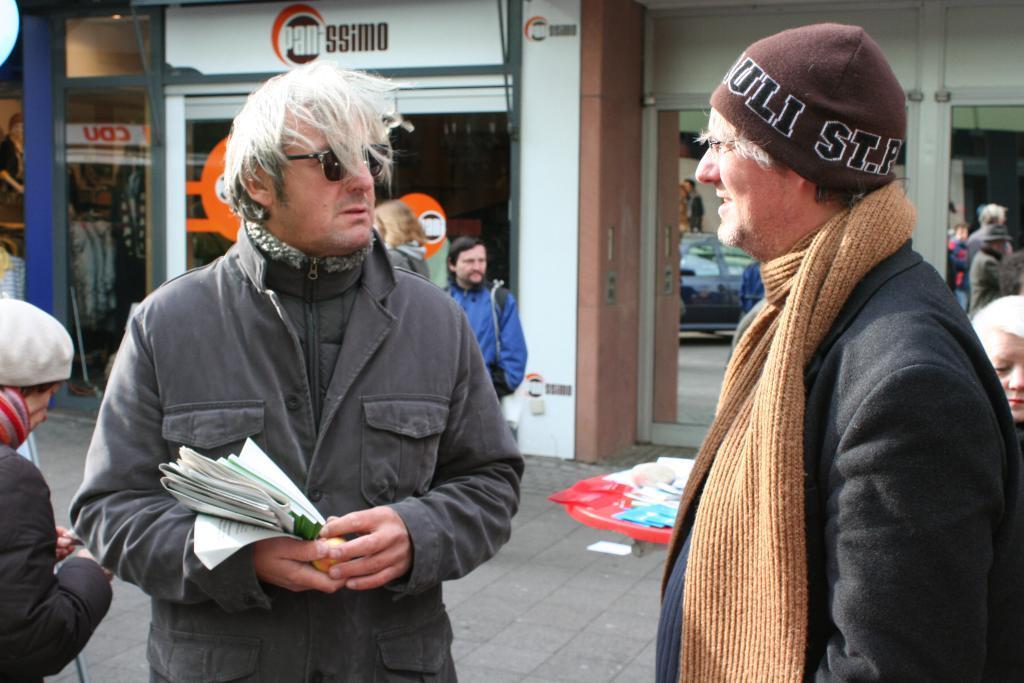Could you give a brief overview of what you see in this image? In this picture I can see there are few people and among them these two persons are wearing sweater and goggles, this person is holding papers and there are stores in the backdrop and there are glass doors to it. 